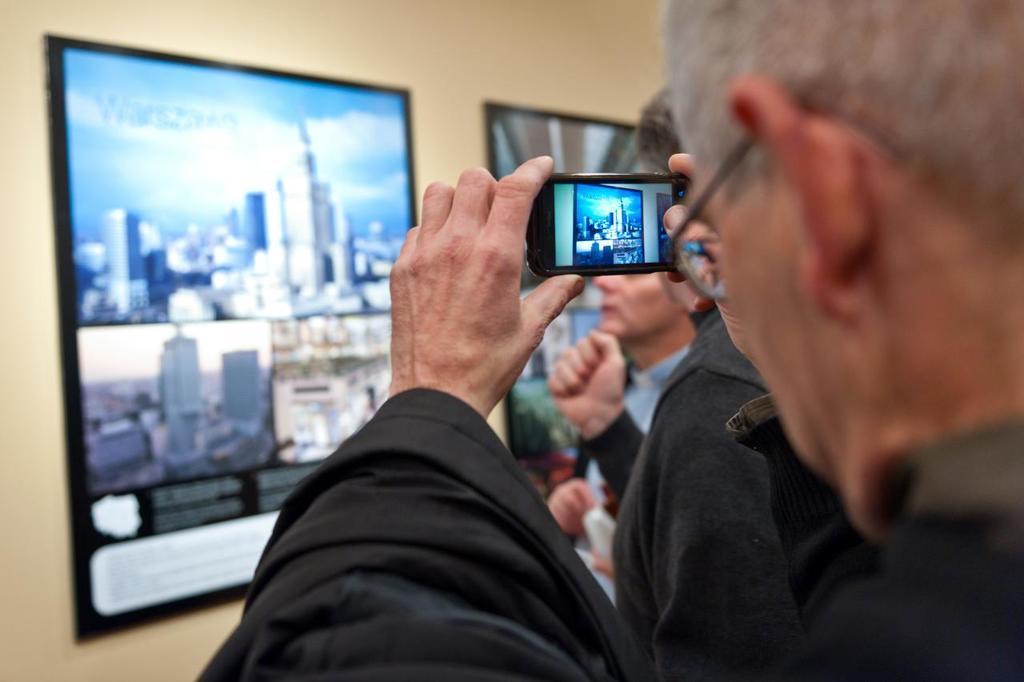Describe this image in one or two sentences. On the background of the picture we can see a wall and few boards. Here in this picture we can see a man who wore spectacles and he is holding a mobile in his hand and taking a snap of this board. Beside to him there are few persons standing. 